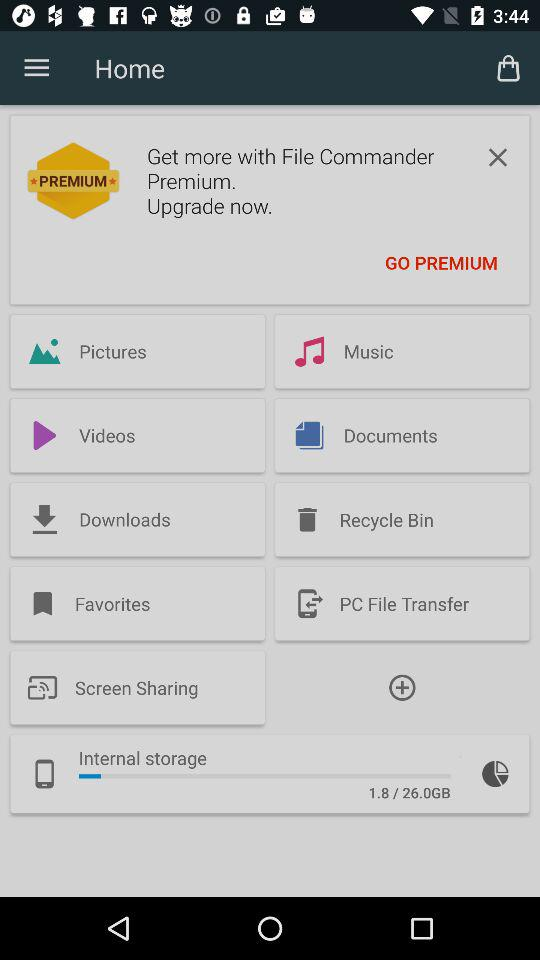How many more GB of storage is available than used?
Answer the question using a single word or phrase. 24.2 